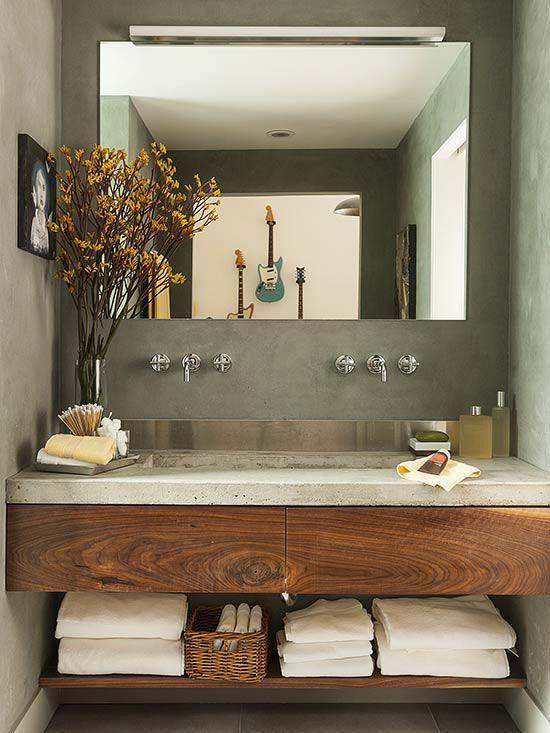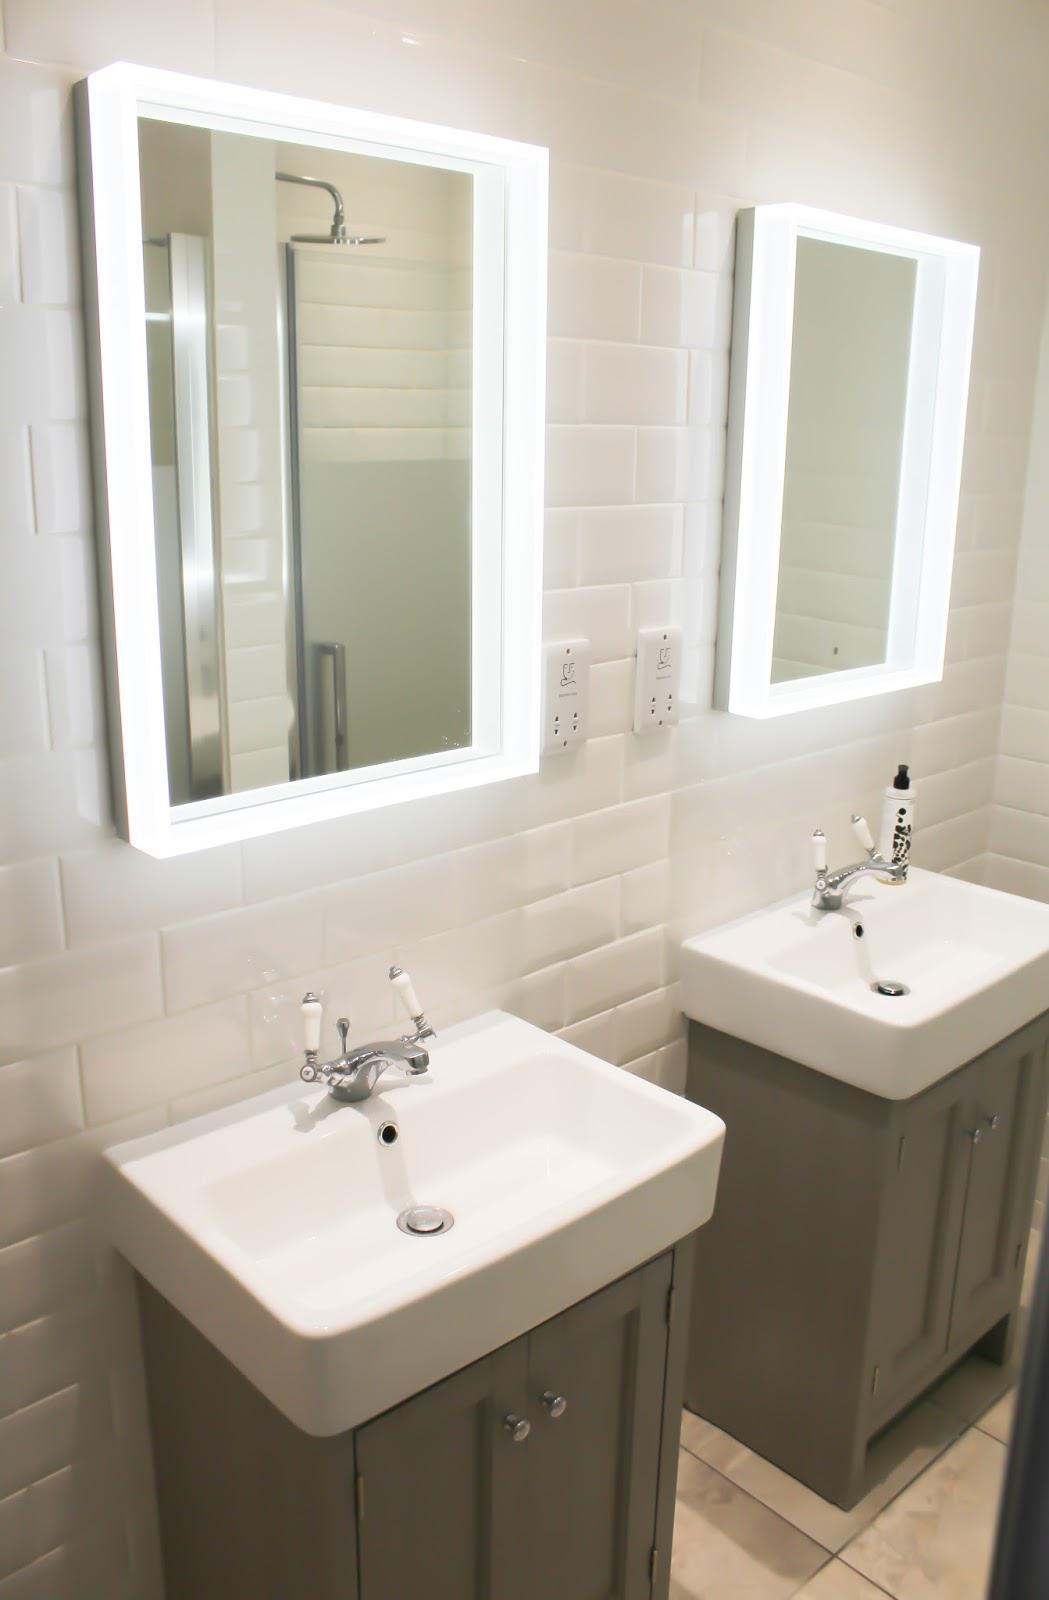The first image is the image on the left, the second image is the image on the right. Considering the images on both sides, is "An area with two bathroom sinks and a glass shower unit can be seen in one image, while the other image shows a single sink and surrounding cabinetry." valid? Answer yes or no. No. The first image is the image on the left, the second image is the image on the right. Examine the images to the left and right. Is the description "Right image shows only one rectangular mirror hanging over only one vanity with one sink, in a room with no bathtub visible." accurate? Answer yes or no. No. 